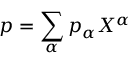<formula> <loc_0><loc_0><loc_500><loc_500>p = \sum _ { \alpha } p _ { \alpha } X ^ { \alpha }</formula> 